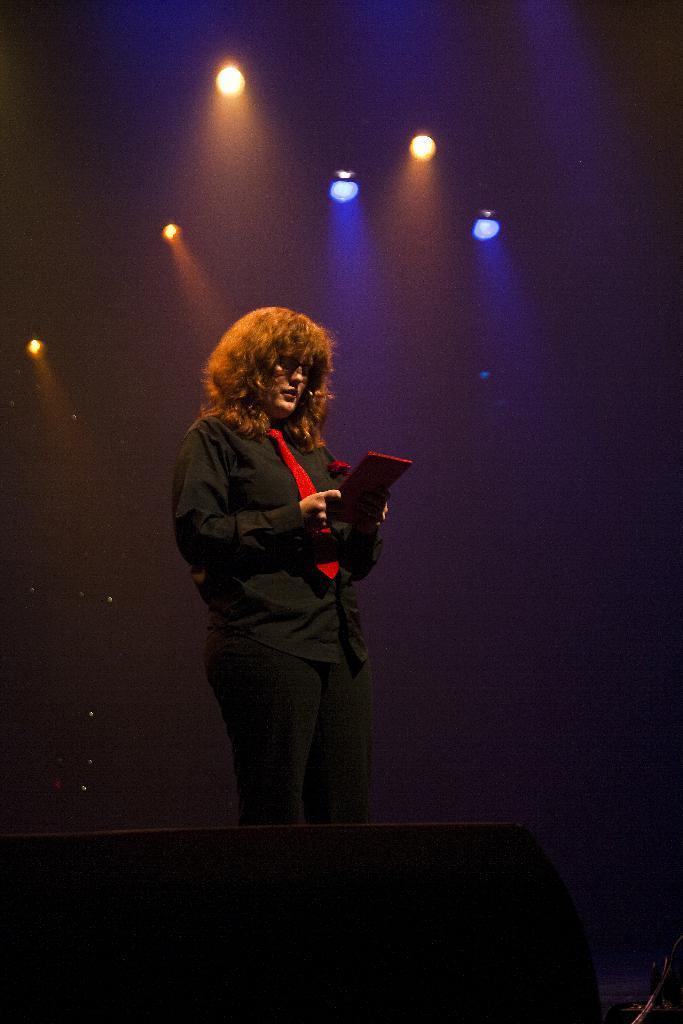How would you summarize this image in a sentence or two? In this picture we can observe a person standing wearing black color dress and red color tie. In the background we can observe yellow and blue color lights. 